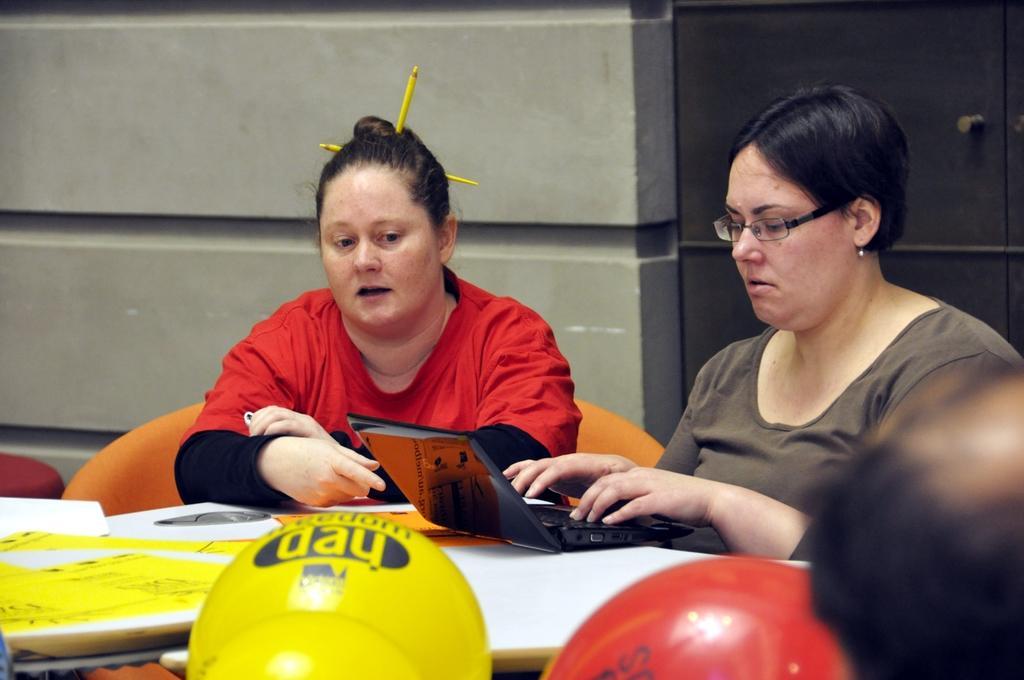How would you summarize this image in a sentence or two? In this image I can see two women are sitting, I can see one of them is wearing red dress and one is wearing specs. I can also see a table and on it I can see yellow colour thing and a laptop. I can also see something is written over here. 